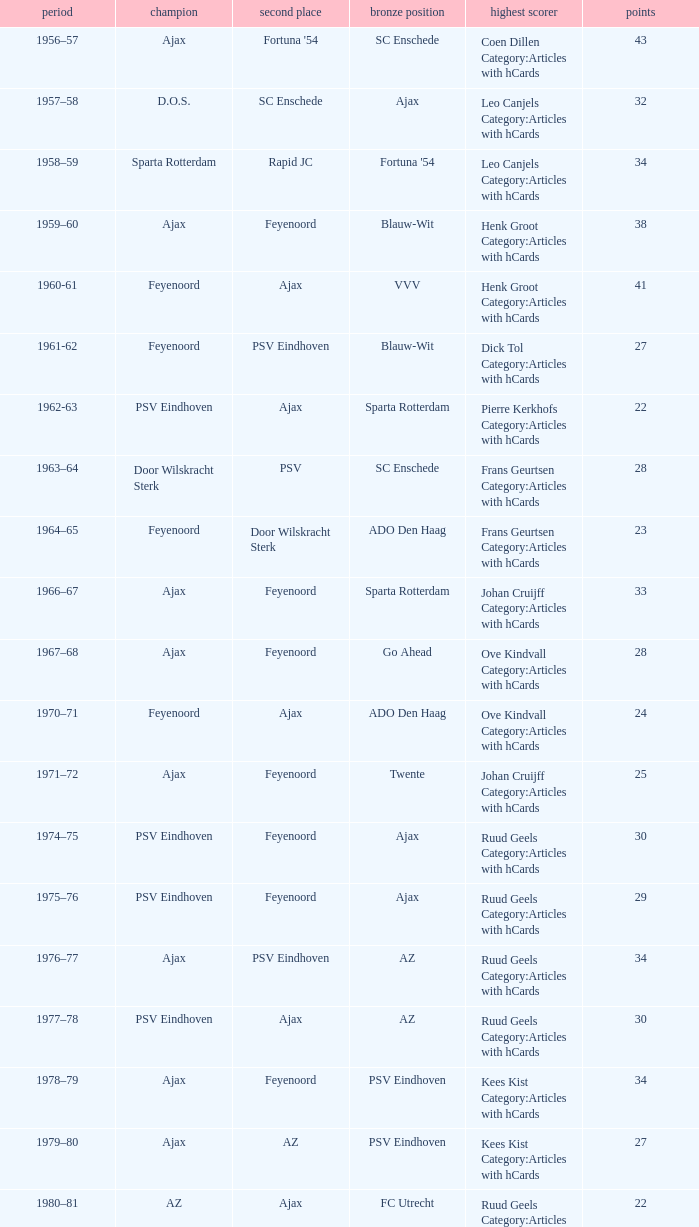When twente came in third place and ajax was the winner what are the seasons? 1971–72, 1989-90. 